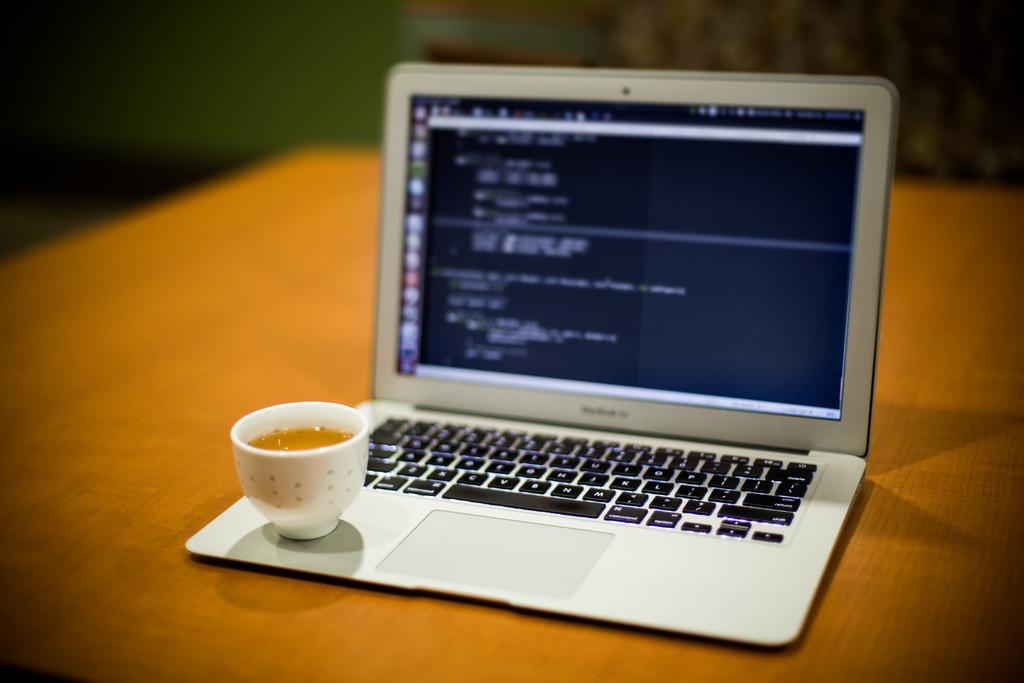What electronic device is present on the wooden platform in the image? There is a laptop on a wooden platform in the image. What beverage is in the cup on the wooden platform? There is a cup with coffee in it on the wooden platform. Can you describe the background of the image? The background of the image is blurry. Is there a veil covering the laptop in the image? No, there is no veil present in the image. Can you see any grapes on the wooden platform in the image? No, there are no grapes present in the image. 